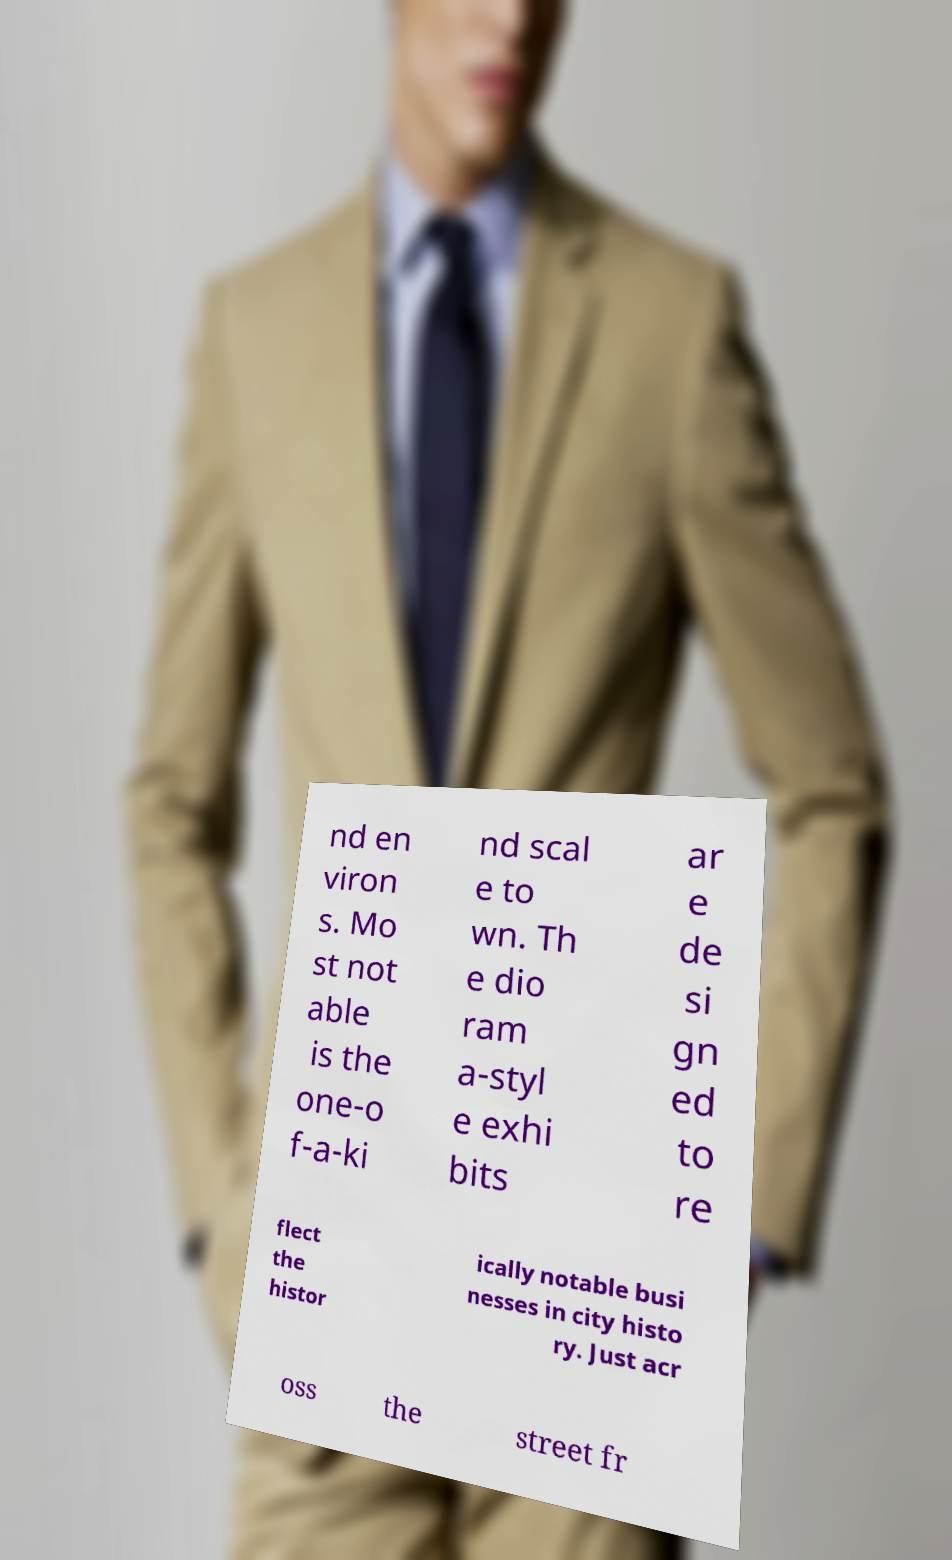Can you accurately transcribe the text from the provided image for me? nd en viron s. Mo st not able is the one-o f-a-ki nd scal e to wn. Th e dio ram a-styl e exhi bits ar e de si gn ed to re flect the histor ically notable busi nesses in city histo ry. Just acr oss the street fr 